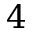<formula> <loc_0><loc_0><loc_500><loc_500>4</formula> 